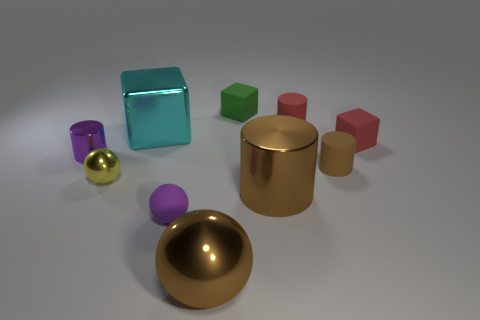The thing that is the same color as the small metal cylinder is what size?
Ensure brevity in your answer.  Small. Are the small purple cylinder and the brown ball made of the same material?
Offer a terse response. Yes. What color is the metal ball that is the same size as the brown shiny cylinder?
Make the answer very short. Brown. The tiny metallic thing that is the same color as the tiny rubber sphere is what shape?
Offer a very short reply. Cylinder. Are the small cylinder that is on the left side of the tiny shiny sphere and the block in front of the cyan object made of the same material?
Keep it short and to the point. No. The small red thing behind the big metal object behind the tiny purple cylinder is what shape?
Keep it short and to the point. Cylinder. Is there anything else that is the same color as the tiny metal cylinder?
Offer a terse response. Yes. Is there a tiny purple shiny cylinder that is left of the cylinder left of the metallic ball that is on the left side of the big brown shiny ball?
Give a very brief answer. No. There is a small cylinder that is to the left of the green rubber block; is it the same color as the rubber object in front of the tiny brown object?
Your response must be concise. Yes. There is a brown object that is the same size as the yellow metal thing; what is it made of?
Keep it short and to the point. Rubber. 